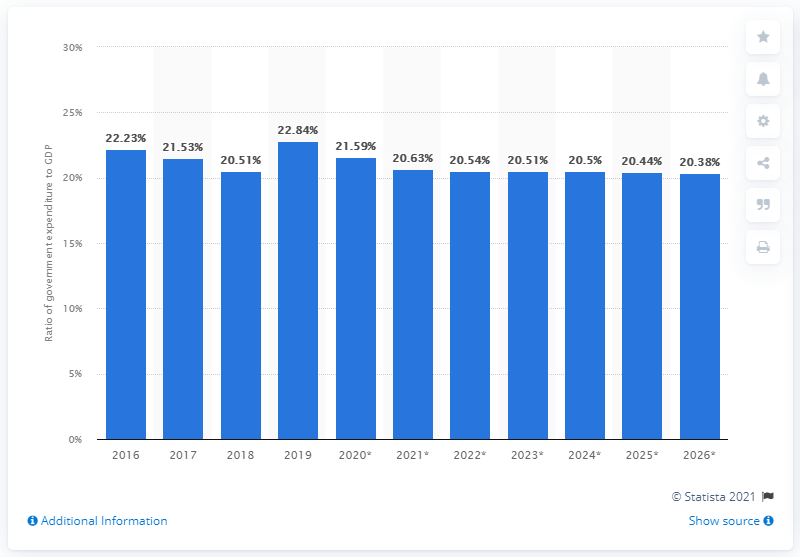Specify some key components in this picture. In 2019, government expenditure in Vietnam accounted for 22.84% of the country's gross domestic product. 